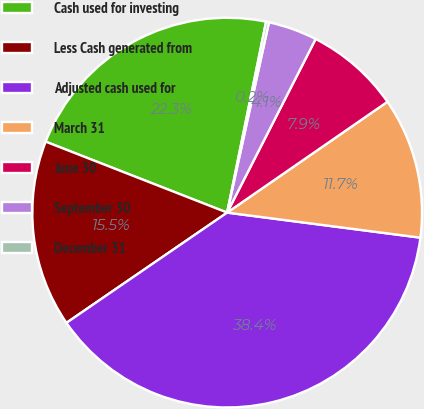<chart> <loc_0><loc_0><loc_500><loc_500><pie_chart><fcel>Cash used for investing<fcel>Less Cash generated from<fcel>Adjusted cash used for<fcel>March 31<fcel>June 30<fcel>September 30<fcel>December 31<nl><fcel>22.27%<fcel>15.5%<fcel>38.38%<fcel>11.68%<fcel>7.87%<fcel>4.06%<fcel>0.24%<nl></chart> 